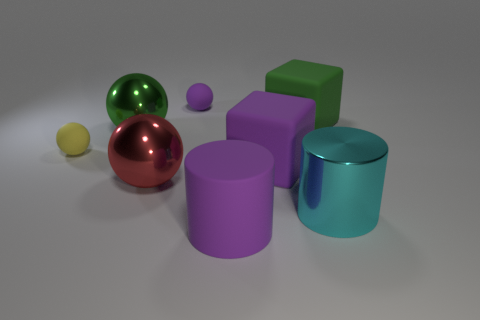Add 2 matte objects. How many objects exist? 10 Subtract all cylinders. How many objects are left? 6 Add 8 red things. How many red things are left? 9 Add 1 matte things. How many matte things exist? 6 Subtract 1 green spheres. How many objects are left? 7 Subtract all yellow matte cubes. Subtract all tiny purple spheres. How many objects are left? 7 